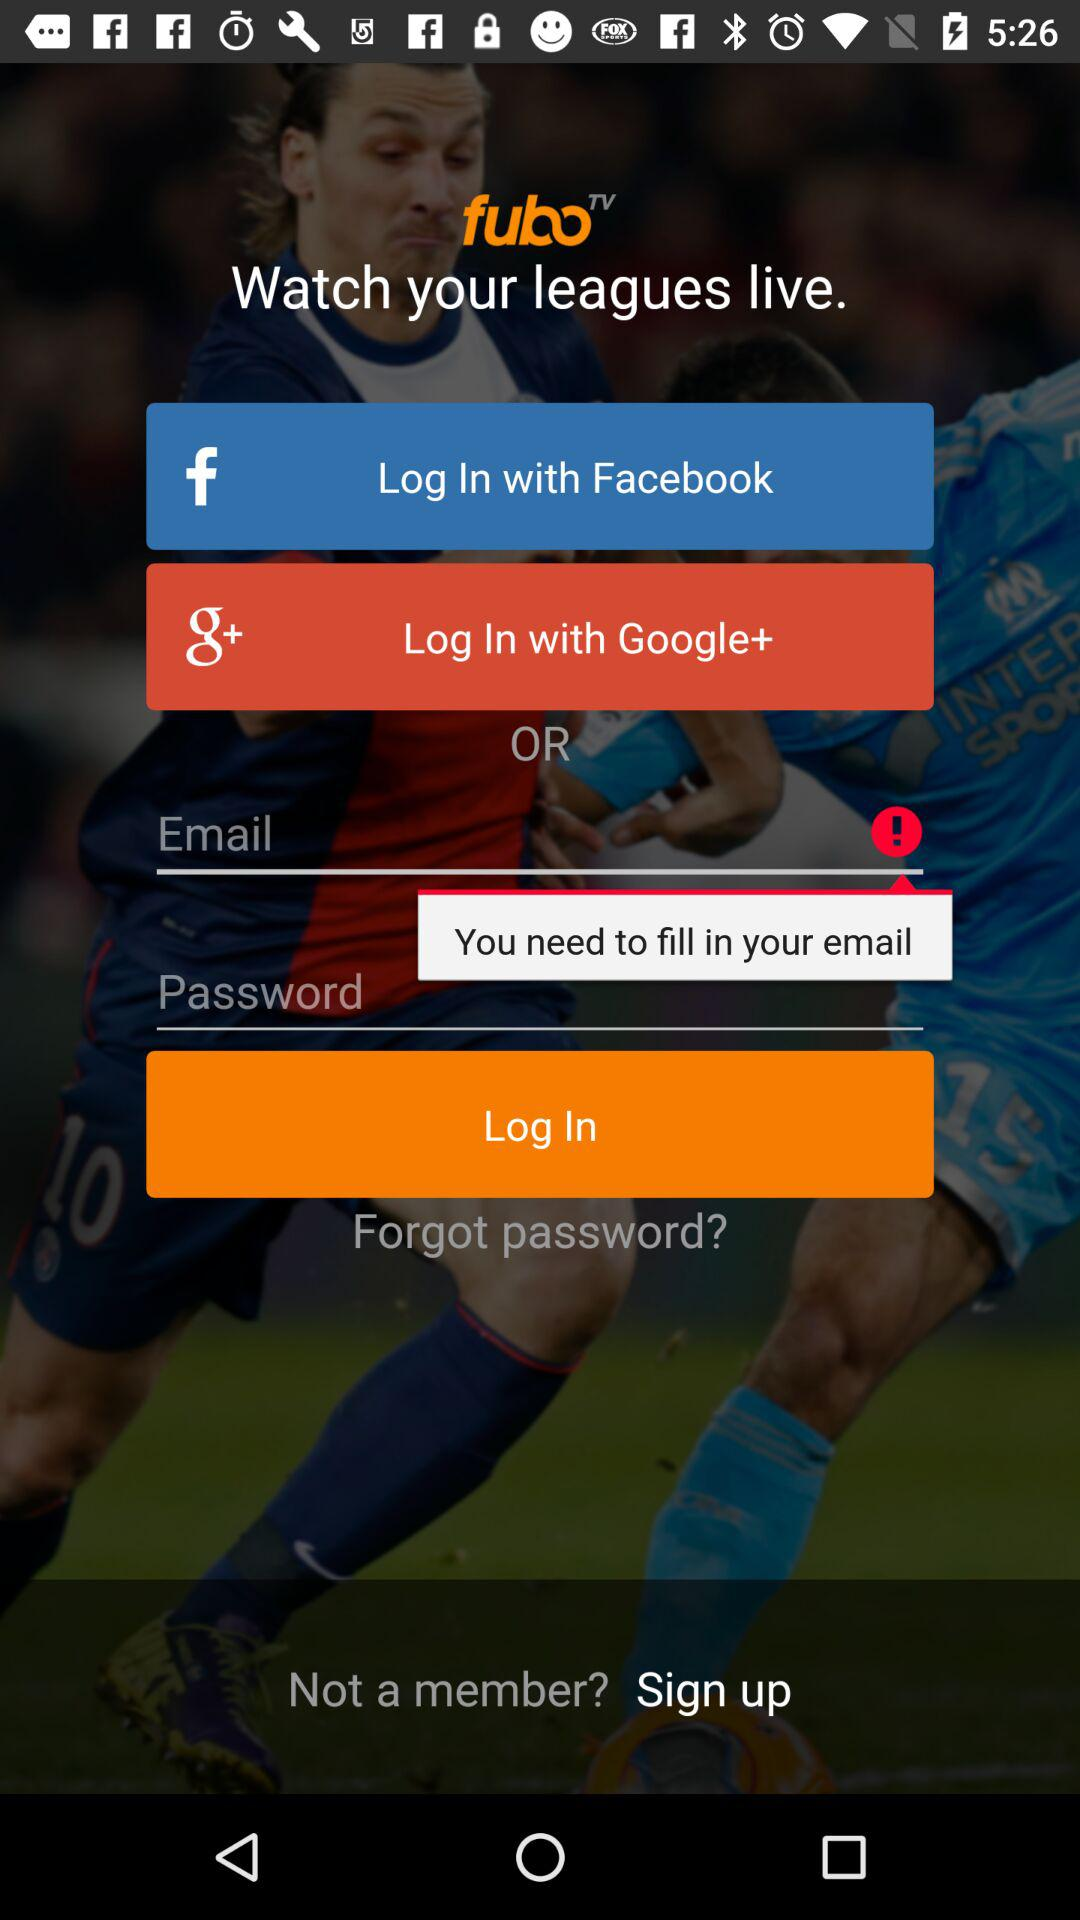What is the name of the application? The name of the application is "fuboTV". 